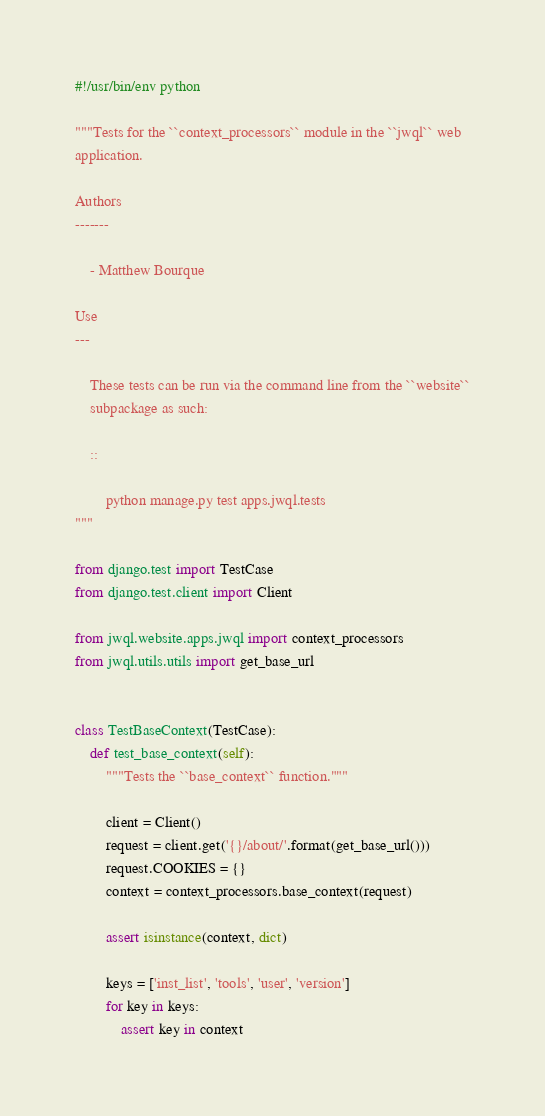Convert code to text. <code><loc_0><loc_0><loc_500><loc_500><_Python_>#!/usr/bin/env python

"""Tests for the ``context_processors`` module in the ``jwql`` web
application.

Authors
-------

    - Matthew Bourque

Use
---

    These tests can be run via the command line from the ``website``
    subpackage as such:

    ::

        python manage.py test apps.jwql.tests
"""

from django.test import TestCase
from django.test.client import Client

from jwql.website.apps.jwql import context_processors
from jwql.utils.utils import get_base_url


class TestBaseContext(TestCase):
    def test_base_context(self):
        """Tests the ``base_context`` function."""

        client = Client()
        request = client.get('{}/about/'.format(get_base_url()))
        request.COOKIES = {}
        context = context_processors.base_context(request)

        assert isinstance(context, dict)

        keys = ['inst_list', 'tools', 'user', 'version']
        for key in keys:
            assert key in context
</code> 